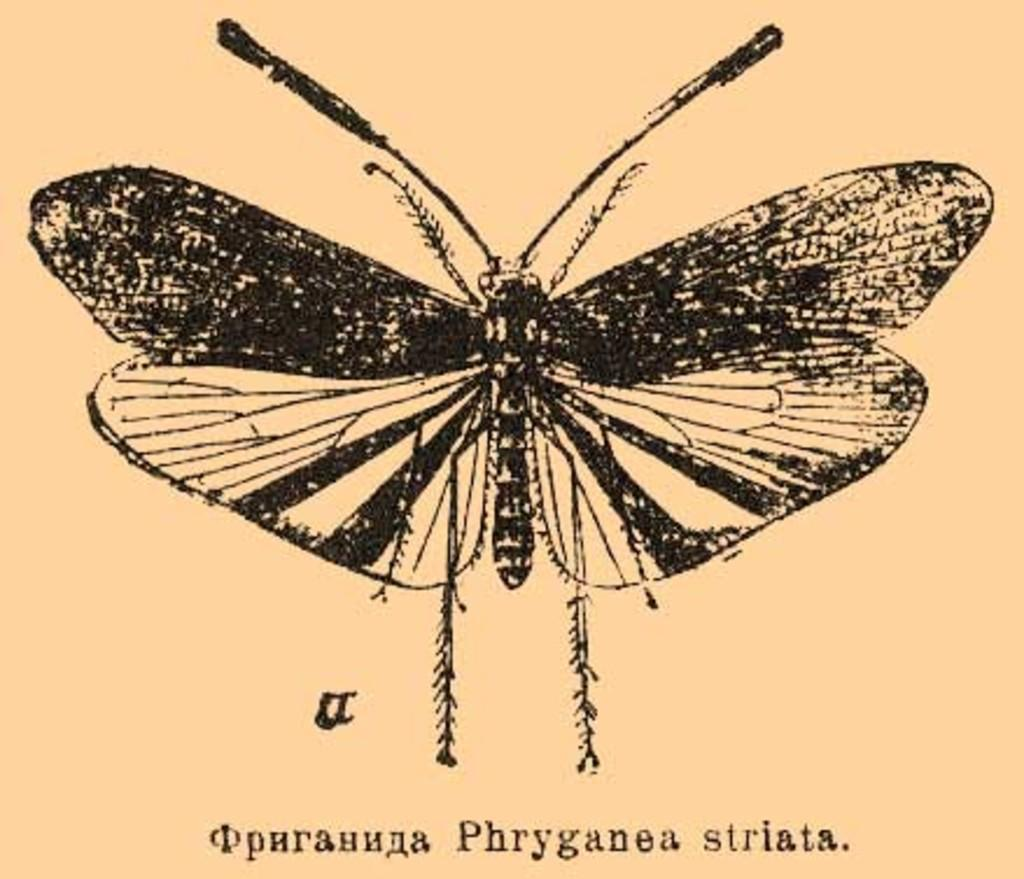What type of animal is present in the image? There is a butterfly in the image. Is there any text present in the image? Yes, there is text written at the bottom of the image. How many jellyfish can be seen swimming in the image? There are no jellyfish present in the image; it features a butterfly and text. What type of sponge is used to clean the butterfly in the image? There is no sponge or cleaning activity depicted in the image. 